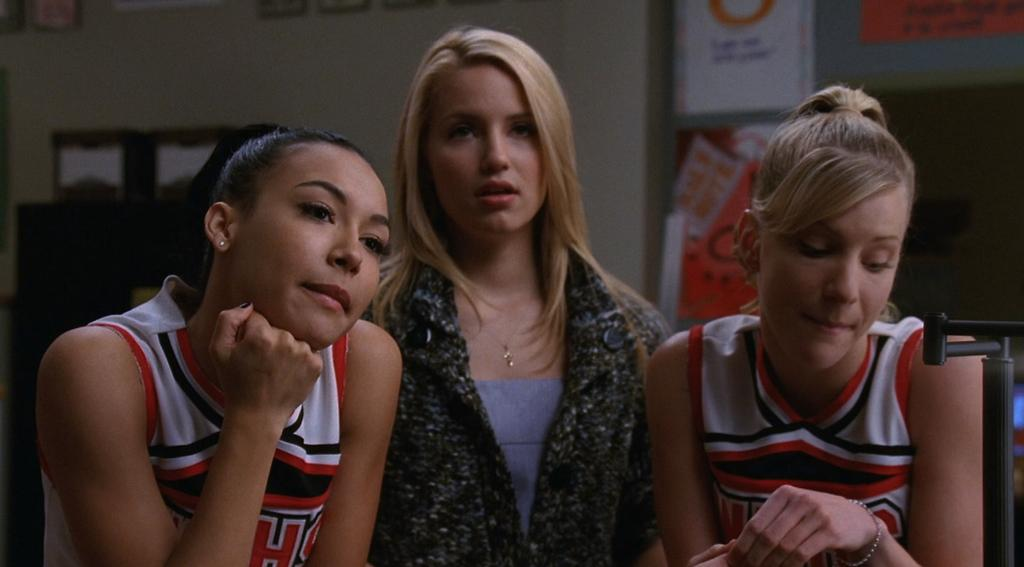What is happening in the center of the image? There are people standing in the center of the image. What can be seen on the wall in the background? There are posters on the wall in the background. What type of decorative items are present in the background? There are frames in the background. Can you describe any other objects visible in the background? There are other objects visible in the background, but their specific details are not mentioned in the provided facts. What is the price of the frame in the image? There is no information about the price of the frame in the image, as the provided facts do not mention any prices. 